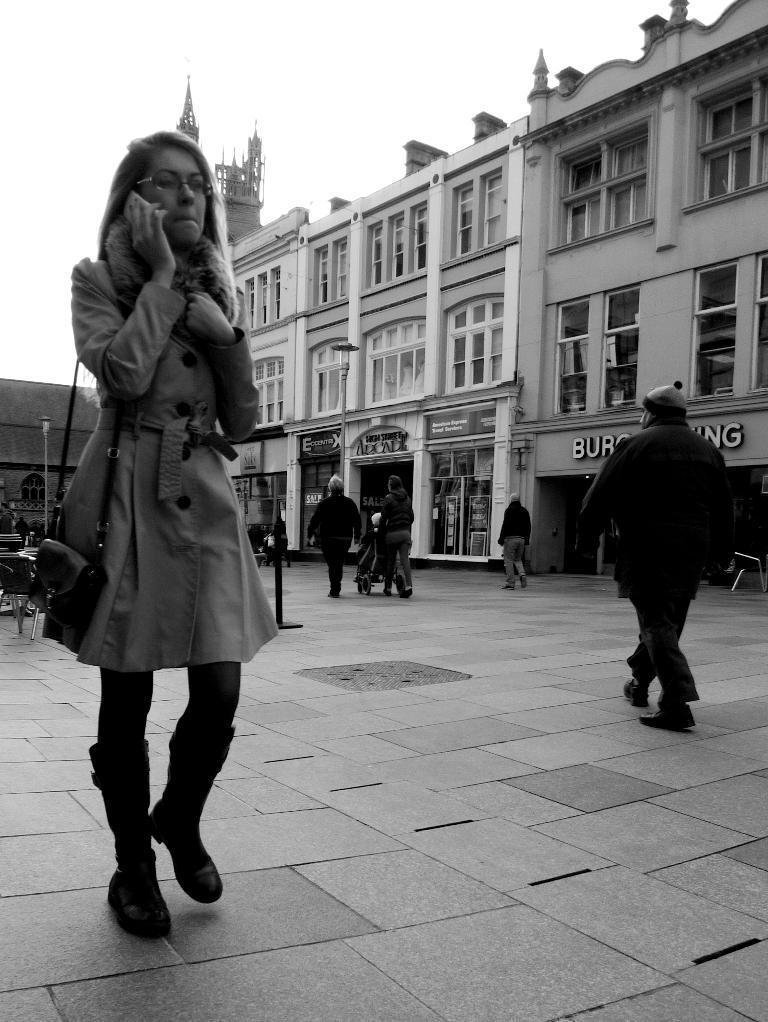In one or two sentences, can you explain what this image depicts? In this image there are many people walking on the street. In the left a lady wearing winter clothes is walking on the street. In the background there are buildings. The sky is clear. 